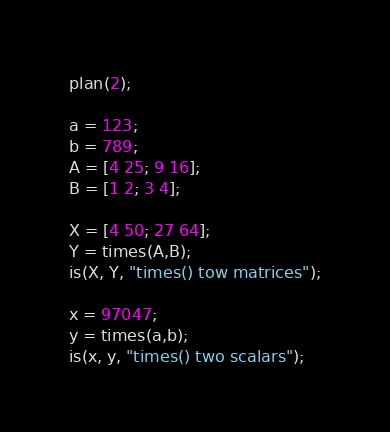Convert code to text. <code><loc_0><loc_0><loc_500><loc_500><_Perl_>plan(2);

a = 123;
b = 789;
A = [4 25; 9 16];
B = [1 2; 3 4];

X = [4 50; 27 64];
Y = times(A,B);
is(X, Y, "times() tow matrices");

x = 97047;
y = times(a,b);
is(x, y, "times() two scalars");
</code> 